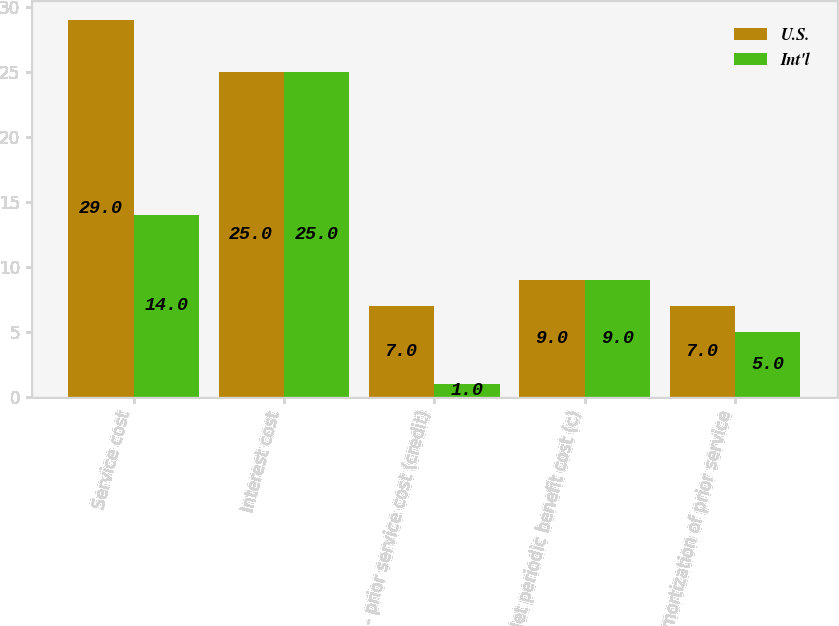Convert chart. <chart><loc_0><loc_0><loc_500><loc_500><stacked_bar_chart><ecel><fcel>Service cost<fcel>Interest cost<fcel>- prior service cost (credit)<fcel>Net periodic benefit cost (c)<fcel>Amortization of prior service<nl><fcel>U.S.<fcel>29<fcel>25<fcel>7<fcel>9<fcel>7<nl><fcel>Int'l<fcel>14<fcel>25<fcel>1<fcel>9<fcel>5<nl></chart> 